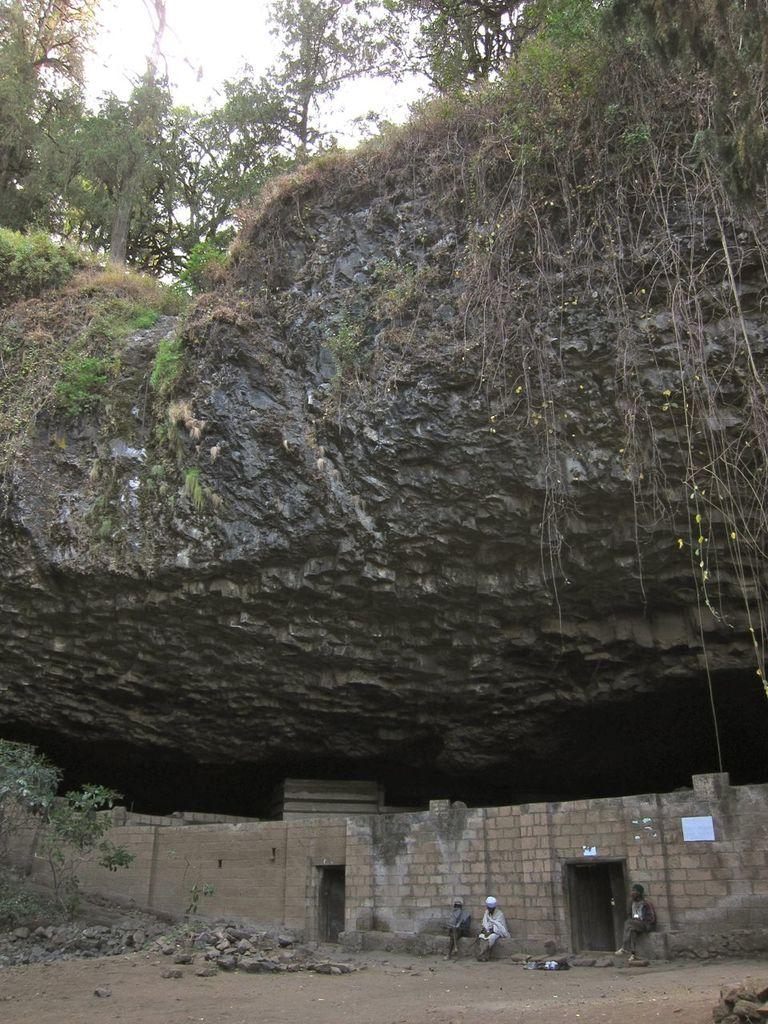What is the main feature in the image? There is a huge rock in the image. What can be seen above the rock? There are trees above the rock. What type of structure is present in the image? There is a brick wall in the image. How many people are located under the rock? There are three persons under the rock. Where is the market located in the image? There is no market present in the image. What type of tool is being used by one of the persons under the rock? The provided facts do not mention any tools being used by the persons under the rock. 